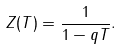<formula> <loc_0><loc_0><loc_500><loc_500>Z ( T ) = \frac { 1 } { 1 - q T } .</formula> 